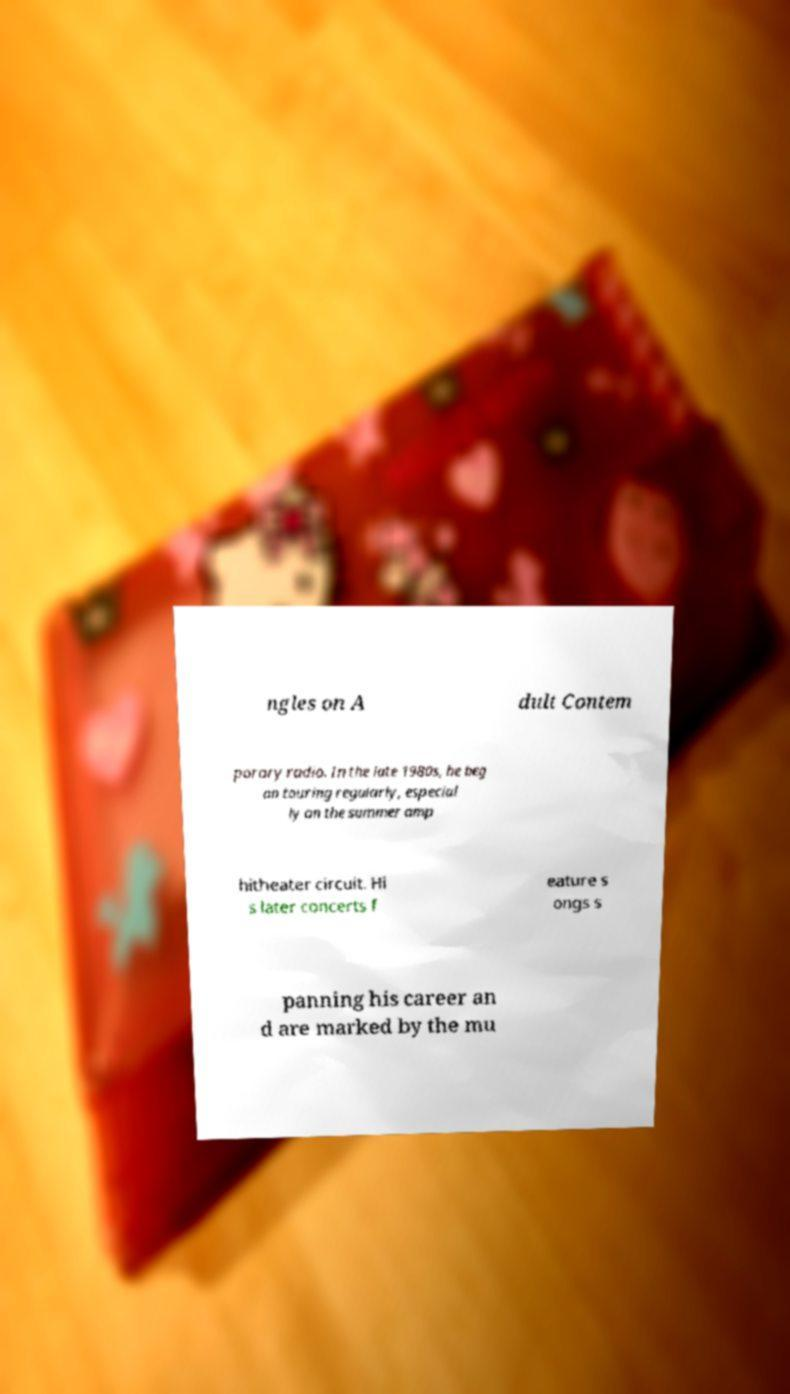Could you extract and type out the text from this image? ngles on A dult Contem porary radio. In the late 1980s, he beg an touring regularly, especial ly on the summer amp hitheater circuit. Hi s later concerts f eature s ongs s panning his career an d are marked by the mu 